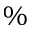Convert formula to latex. <formula><loc_0><loc_0><loc_500><loc_500>\%</formula> 